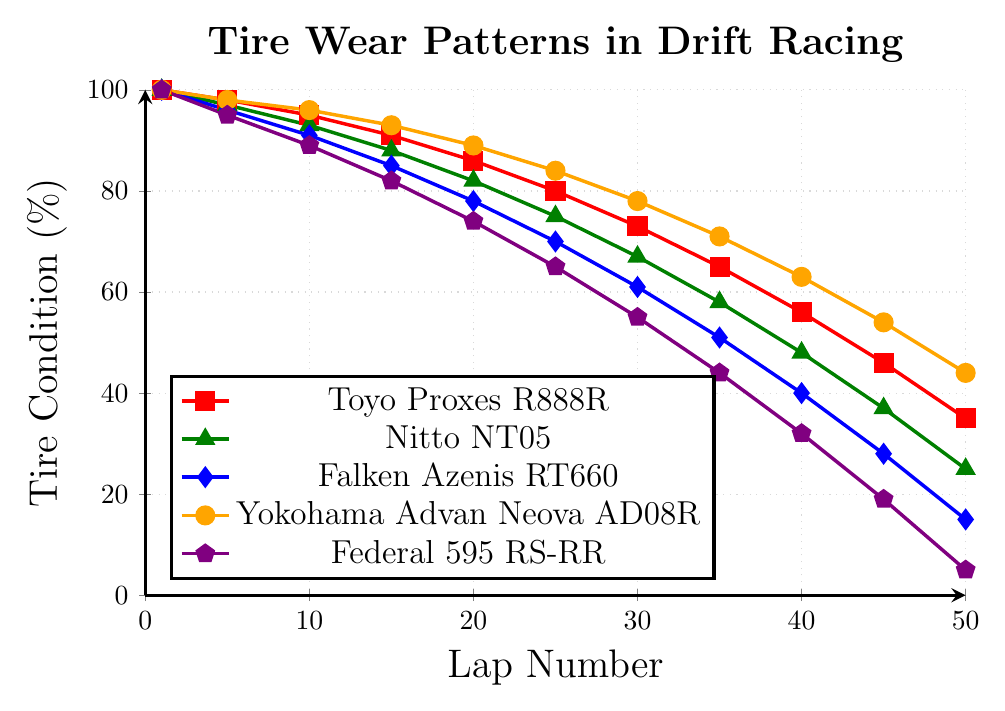What's the tire condition of Federal 595 RS-RR at Lap 25? At Lap 25, the Federal 595 RS-RR tire condition data point can be read directly from the figure. We look for the pentagon marker on the plot corresponding to the lap number 25.
Answer: 65 Which tire compound has the least wear at Lap 50? To determine which tire compound has the least wear, we compare the tire conditions of all compounds at Lap 50. Toyo Proxes R888R has 35%, Nitto NT05 has 25%, Falken Azenis RT660 has 15%, Yokohama Advan Neova AD08R has 44%, and Federal 595 RS-RR has 5%. The highest tire condition value is 44% for the Yokohama Advan Neova AD08R.
Answer: Yokohama Advan Neova AD08R How much more wear does the Falken Azenis RT660 have compared to the Yokohama Advan Neova AD08R at Lap 20? At Lap 20, the Falken Azenis RT660 tire condition is 78% and the Yokohama Advan Neova AD08R tire condition is 89%. The difference in wear is 89% - 78% = 11%.
Answer: 11% Which tire retains at least 50% of its condition longer: Nitto NT05 or Federal 595 RS-RR? We need to find the lap number where each tire compound falls below 50% condition. The Nitto NT05 falls below 50% after Lap 40 and the Federal 595 RS-RR falls below 50% after Lap 30. Since Nitto NT05 retains at least 50% of its condition up to Lap 40, which is longer than Federal 595 RS-RR, the Nitto NT05 lasts longer.
Answer: Nitto NT05 What is the average tire condition for Toyo Proxes R888R at Laps 10, 20, and 30? The tire conditions for Toyo Proxes R888R at these laps are 95%, 86%, and 73%. To find the average: (95% + 86% + 73%) / 3 = 254% / 3 ≈ 84.67%.
Answer: 84.67% By how much does the tire condition of Yokohama Advan Neova AD08R decrease from Lap 1 to Lap 25? Initially, at Lap 1, Yokohama Advan Neova AD08R is at 100%. At Lap 25, it is 84%. The decrease is 100% - 84% = 16%.
Answer: 16% Which tire compound shows the steepest wear between Lap 30 and Lap 50? To determine the steepest wear, we compare the change in tire condition between Lap 30 and Lap 50 for each compound. Calculations are as follows:
- Toyo Proxes R888R: 73% to 35% = 38%
- Nitto NT05: 67% to 25% = 42%
- Falken Azenis RT660: 61% to 15% = 46%
- Yokohama Advan Neova AD08R: 78% to 44% = 34%
- Federal 595 RS-RR: 55% to 5% = 50%
Federal 595 RS-RR shows the steepest wear of 50%.
Answer: Federal 595 RS-RR 